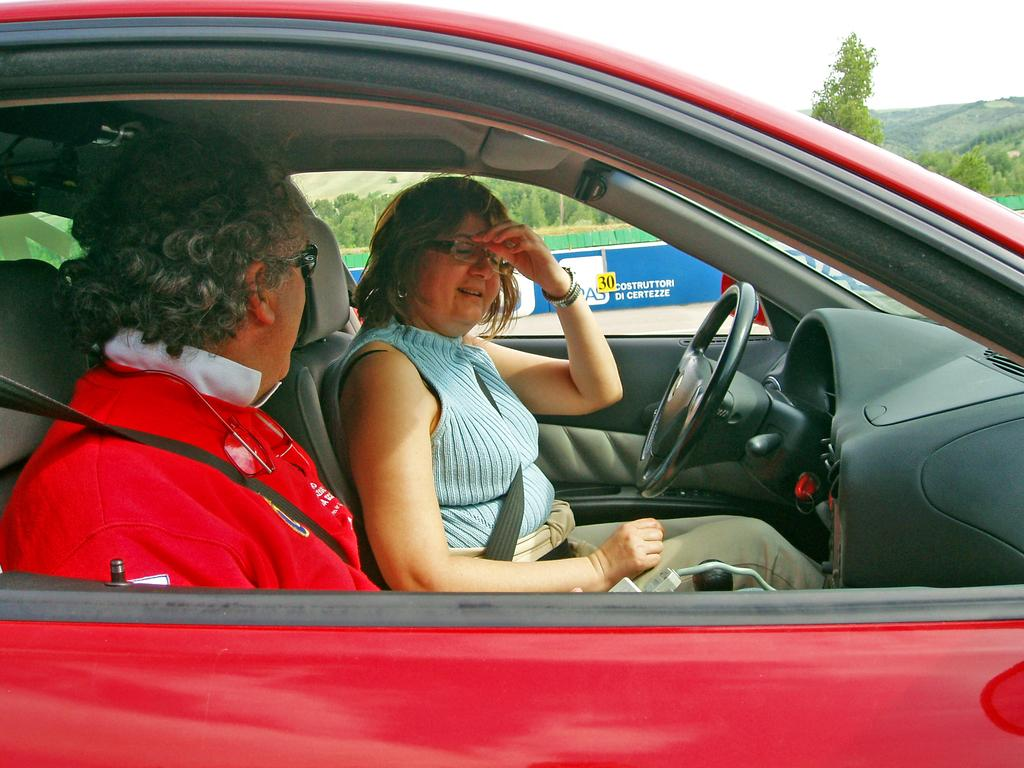How many people are inside the car in the image? There are two persons sitting inside a red car in the image. What is the primary control mechanism for the car? The car has a steering wheel. What can be seen in the distance beyond the car? There are multiple trees visible in the distance. What type of beef is being served at the restaurant in the image? There is no restaurant or beef present in the image; it features two persons sitting inside a red car. How many frogs are visible on the car's hood in the image? There are no frogs visible on the car's hood in the image. 